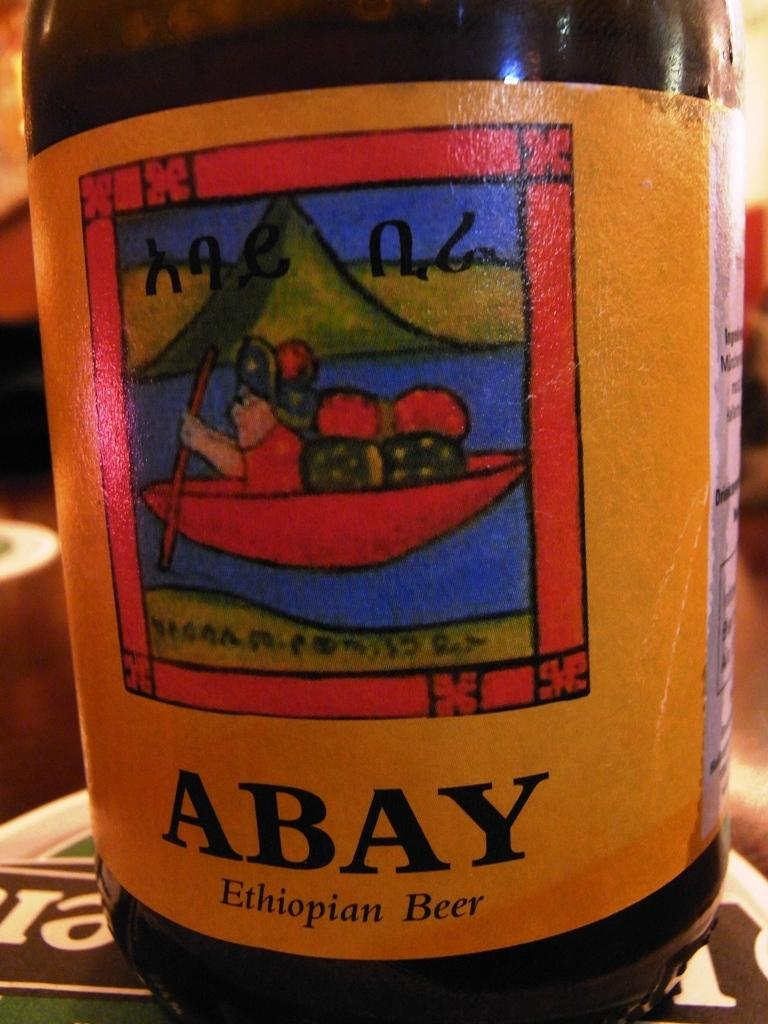<image>
Relay a brief, clear account of the picture shown. A bottle of Ethiopian beer that is called Abay. 